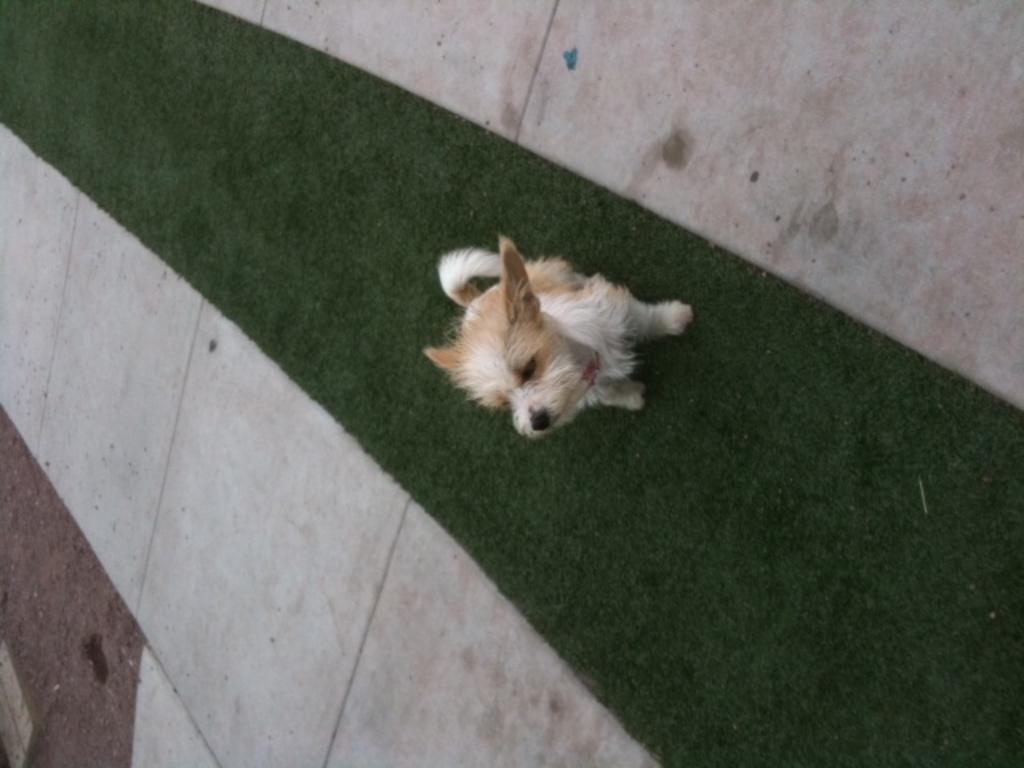In one or two sentences, can you explain what this image depicts? In this image there is a dog sitting on the mat on either side of the mat there are white tiles. 